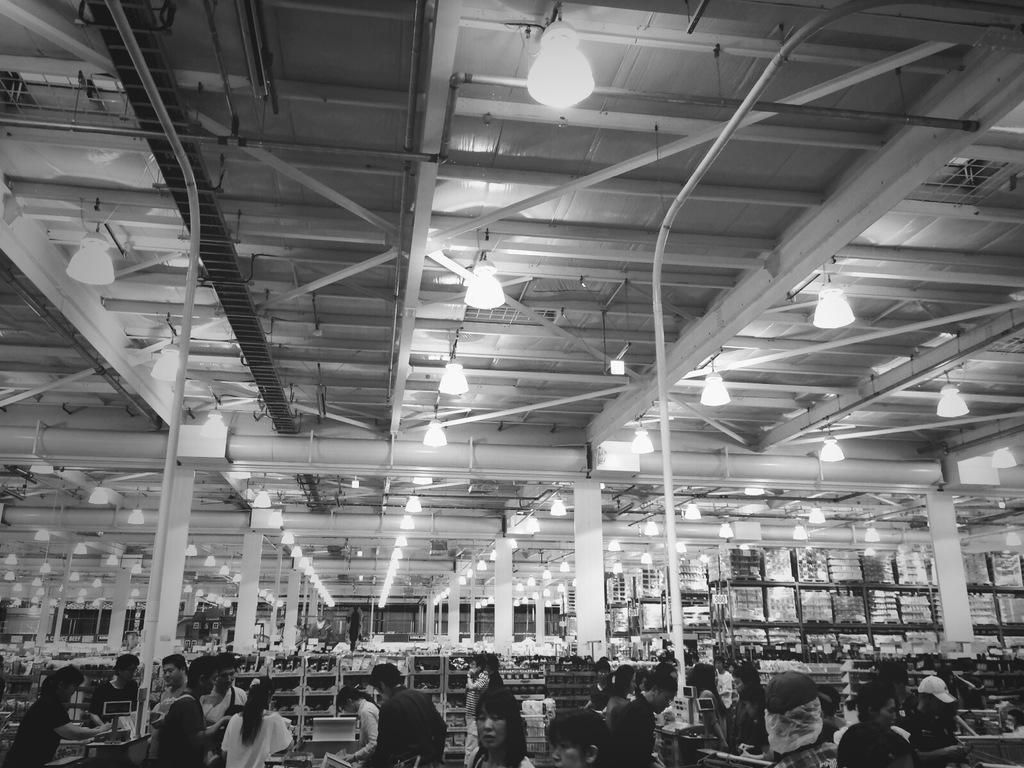Please provide a concise description of this image. This is the black and white image where we can see many people in the store, we can see shelves with protects, rods and the lights to the ceiling. 